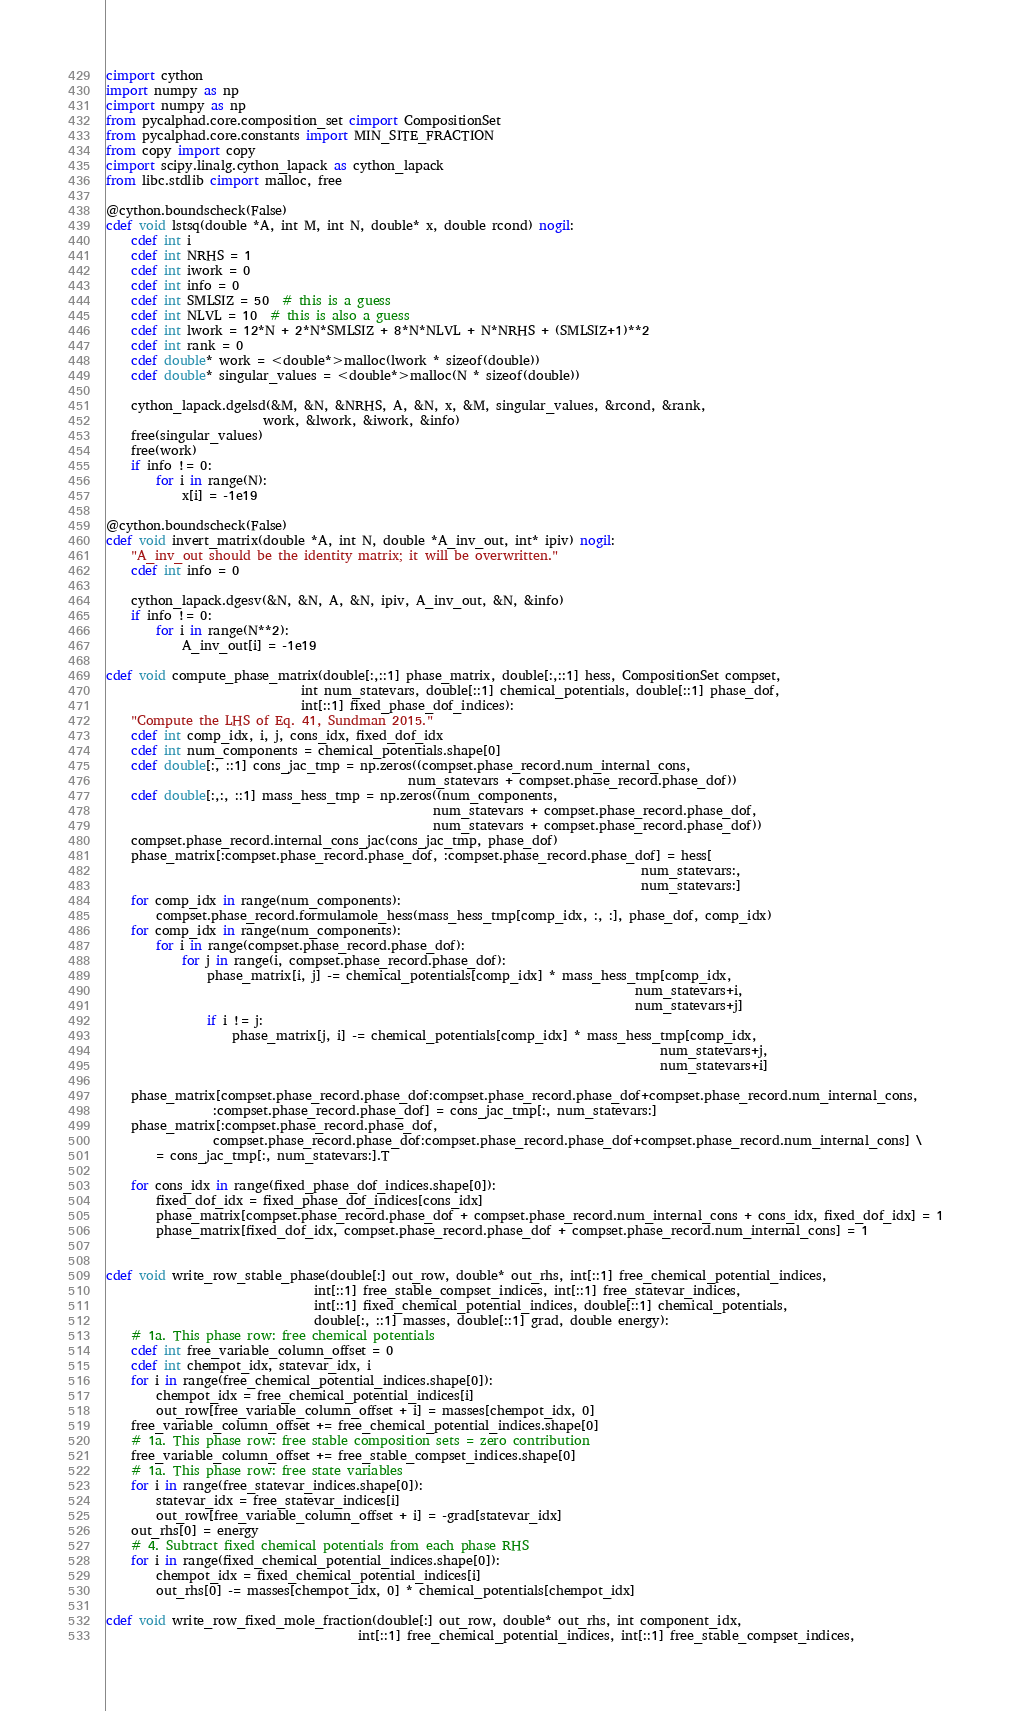<code> <loc_0><loc_0><loc_500><loc_500><_Cython_>cimport cython
import numpy as np
cimport numpy as np
from pycalphad.core.composition_set cimport CompositionSet
from pycalphad.core.constants import MIN_SITE_FRACTION
from copy import copy
cimport scipy.linalg.cython_lapack as cython_lapack
from libc.stdlib cimport malloc, free

@cython.boundscheck(False)
cdef void lstsq(double *A, int M, int N, double* x, double rcond) nogil:
    cdef int i
    cdef int NRHS = 1
    cdef int iwork = 0
    cdef int info = 0
    cdef int SMLSIZ = 50  # this is a guess
    cdef int NLVL = 10  # this is also a guess
    cdef int lwork = 12*N + 2*N*SMLSIZ + 8*N*NLVL + N*NRHS + (SMLSIZ+1)**2
    cdef int rank = 0
    cdef double* work = <double*>malloc(lwork * sizeof(double))
    cdef double* singular_values = <double*>malloc(N * sizeof(double))

    cython_lapack.dgelsd(&M, &N, &NRHS, A, &N, x, &M, singular_values, &rcond, &rank,
                         work, &lwork, &iwork, &info)
    free(singular_values)
    free(work)
    if info != 0:
        for i in range(N):
            x[i] = -1e19

@cython.boundscheck(False)
cdef void invert_matrix(double *A, int N, double *A_inv_out, int* ipiv) nogil:
    "A_inv_out should be the identity matrix; it will be overwritten."
    cdef int info = 0

    cython_lapack.dgesv(&N, &N, A, &N, ipiv, A_inv_out, &N, &info)
    if info != 0:
        for i in range(N**2):
            A_inv_out[i] = -1e19

cdef void compute_phase_matrix(double[:,::1] phase_matrix, double[:,::1] hess, CompositionSet compset,
                               int num_statevars, double[::1] chemical_potentials, double[::1] phase_dof,
                               int[::1] fixed_phase_dof_indices):
    "Compute the LHS of Eq. 41, Sundman 2015."
    cdef int comp_idx, i, j, cons_idx, fixed_dof_idx
    cdef int num_components = chemical_potentials.shape[0]
    cdef double[:, ::1] cons_jac_tmp = np.zeros((compset.phase_record.num_internal_cons,
                                                num_statevars + compset.phase_record.phase_dof))
    cdef double[:,:, ::1] mass_hess_tmp = np.zeros((num_components,
                                                    num_statevars + compset.phase_record.phase_dof,
                                                    num_statevars + compset.phase_record.phase_dof))
    compset.phase_record.internal_cons_jac(cons_jac_tmp, phase_dof)
    phase_matrix[:compset.phase_record.phase_dof, :compset.phase_record.phase_dof] = hess[
                                                                                     num_statevars:,
                                                                                     num_statevars:]
    for comp_idx in range(num_components):
        compset.phase_record.formulamole_hess(mass_hess_tmp[comp_idx, :, :], phase_dof, comp_idx)
    for comp_idx in range(num_components):
        for i in range(compset.phase_record.phase_dof):
            for j in range(i, compset.phase_record.phase_dof):
                phase_matrix[i, j] -= chemical_potentials[comp_idx] * mass_hess_tmp[comp_idx,
                                                                                    num_statevars+i,
                                                                                    num_statevars+j]
                if i != j:
                    phase_matrix[j, i] -= chemical_potentials[comp_idx] * mass_hess_tmp[comp_idx,
                                                                                        num_statevars+j,
                                                                                        num_statevars+i]

    phase_matrix[compset.phase_record.phase_dof:compset.phase_record.phase_dof+compset.phase_record.num_internal_cons,
                 :compset.phase_record.phase_dof] = cons_jac_tmp[:, num_statevars:]
    phase_matrix[:compset.phase_record.phase_dof,
                 compset.phase_record.phase_dof:compset.phase_record.phase_dof+compset.phase_record.num_internal_cons] \
        = cons_jac_tmp[:, num_statevars:].T

    for cons_idx in range(fixed_phase_dof_indices.shape[0]):
        fixed_dof_idx = fixed_phase_dof_indices[cons_idx]
        phase_matrix[compset.phase_record.phase_dof + compset.phase_record.num_internal_cons + cons_idx, fixed_dof_idx] = 1
        phase_matrix[fixed_dof_idx, compset.phase_record.phase_dof + compset.phase_record.num_internal_cons] = 1


cdef void write_row_stable_phase(double[:] out_row, double* out_rhs, int[::1] free_chemical_potential_indices,
                                 int[::1] free_stable_compset_indices, int[::1] free_statevar_indices,
                                 int[::1] fixed_chemical_potential_indices, double[::1] chemical_potentials,
                                 double[:, ::1] masses, double[::1] grad, double energy):
    # 1a. This phase row: free chemical potentials
    cdef int free_variable_column_offset = 0
    cdef int chempot_idx, statevar_idx, i
    for i in range(free_chemical_potential_indices.shape[0]):
        chempot_idx = free_chemical_potential_indices[i]
        out_row[free_variable_column_offset + i] = masses[chempot_idx, 0]
    free_variable_column_offset += free_chemical_potential_indices.shape[0]
    # 1a. This phase row: free stable composition sets = zero contribution
    free_variable_column_offset += free_stable_compset_indices.shape[0]
    # 1a. This phase row: free state variables
    for i in range(free_statevar_indices.shape[0]):
        statevar_idx = free_statevar_indices[i]
        out_row[free_variable_column_offset + i] = -grad[statevar_idx]
    out_rhs[0] = energy
    # 4. Subtract fixed chemical potentials from each phase RHS
    for i in range(fixed_chemical_potential_indices.shape[0]):
        chempot_idx = fixed_chemical_potential_indices[i]
        out_rhs[0] -= masses[chempot_idx, 0] * chemical_potentials[chempot_idx]

cdef void write_row_fixed_mole_fraction(double[:] out_row, double* out_rhs, int component_idx,
                                        int[::1] free_chemical_potential_indices, int[::1] free_stable_compset_indices,</code> 